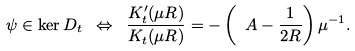<formula> <loc_0><loc_0><loc_500><loc_500>\psi \in \ker D _ { t } \ \Leftrightarrow \ \frac { K ^ { \prime } _ { t } ( \mu R ) } { K _ { t } ( \mu R ) } = - \left ( \ A - \frac { 1 } { 2 R } \right ) \mu ^ { - 1 } .</formula> 